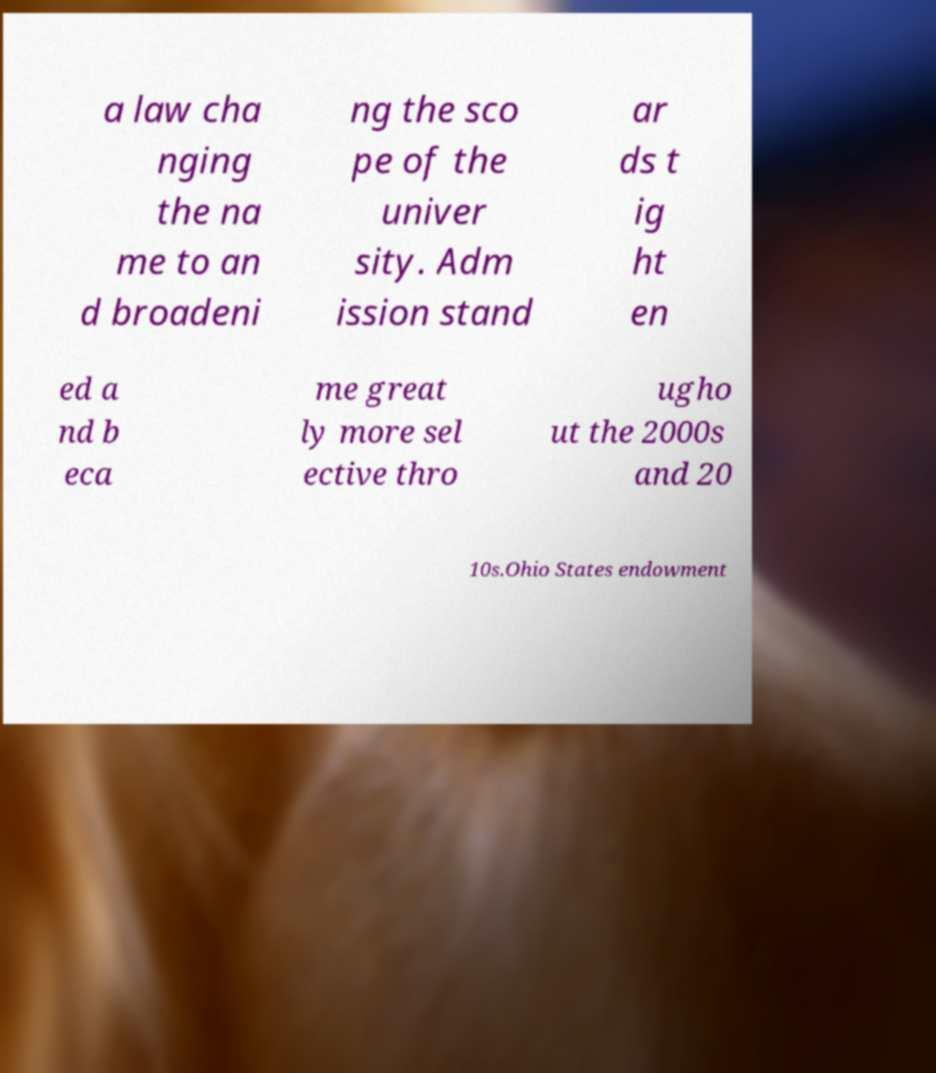Please read and relay the text visible in this image. What does it say? a law cha nging the na me to an d broadeni ng the sco pe of the univer sity. Adm ission stand ar ds t ig ht en ed a nd b eca me great ly more sel ective thro ugho ut the 2000s and 20 10s.Ohio States endowment 